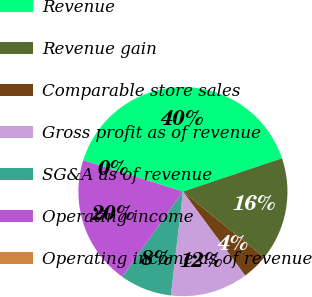<chart> <loc_0><loc_0><loc_500><loc_500><pie_chart><fcel>Revenue<fcel>Revenue gain<fcel>Comparable store sales<fcel>Gross profit as of revenue<fcel>SG&A as of revenue<fcel>Operating income<fcel>Operating income as of revenue<nl><fcel>39.97%<fcel>16.0%<fcel>4.01%<fcel>12.0%<fcel>8.01%<fcel>19.99%<fcel>0.01%<nl></chart> 